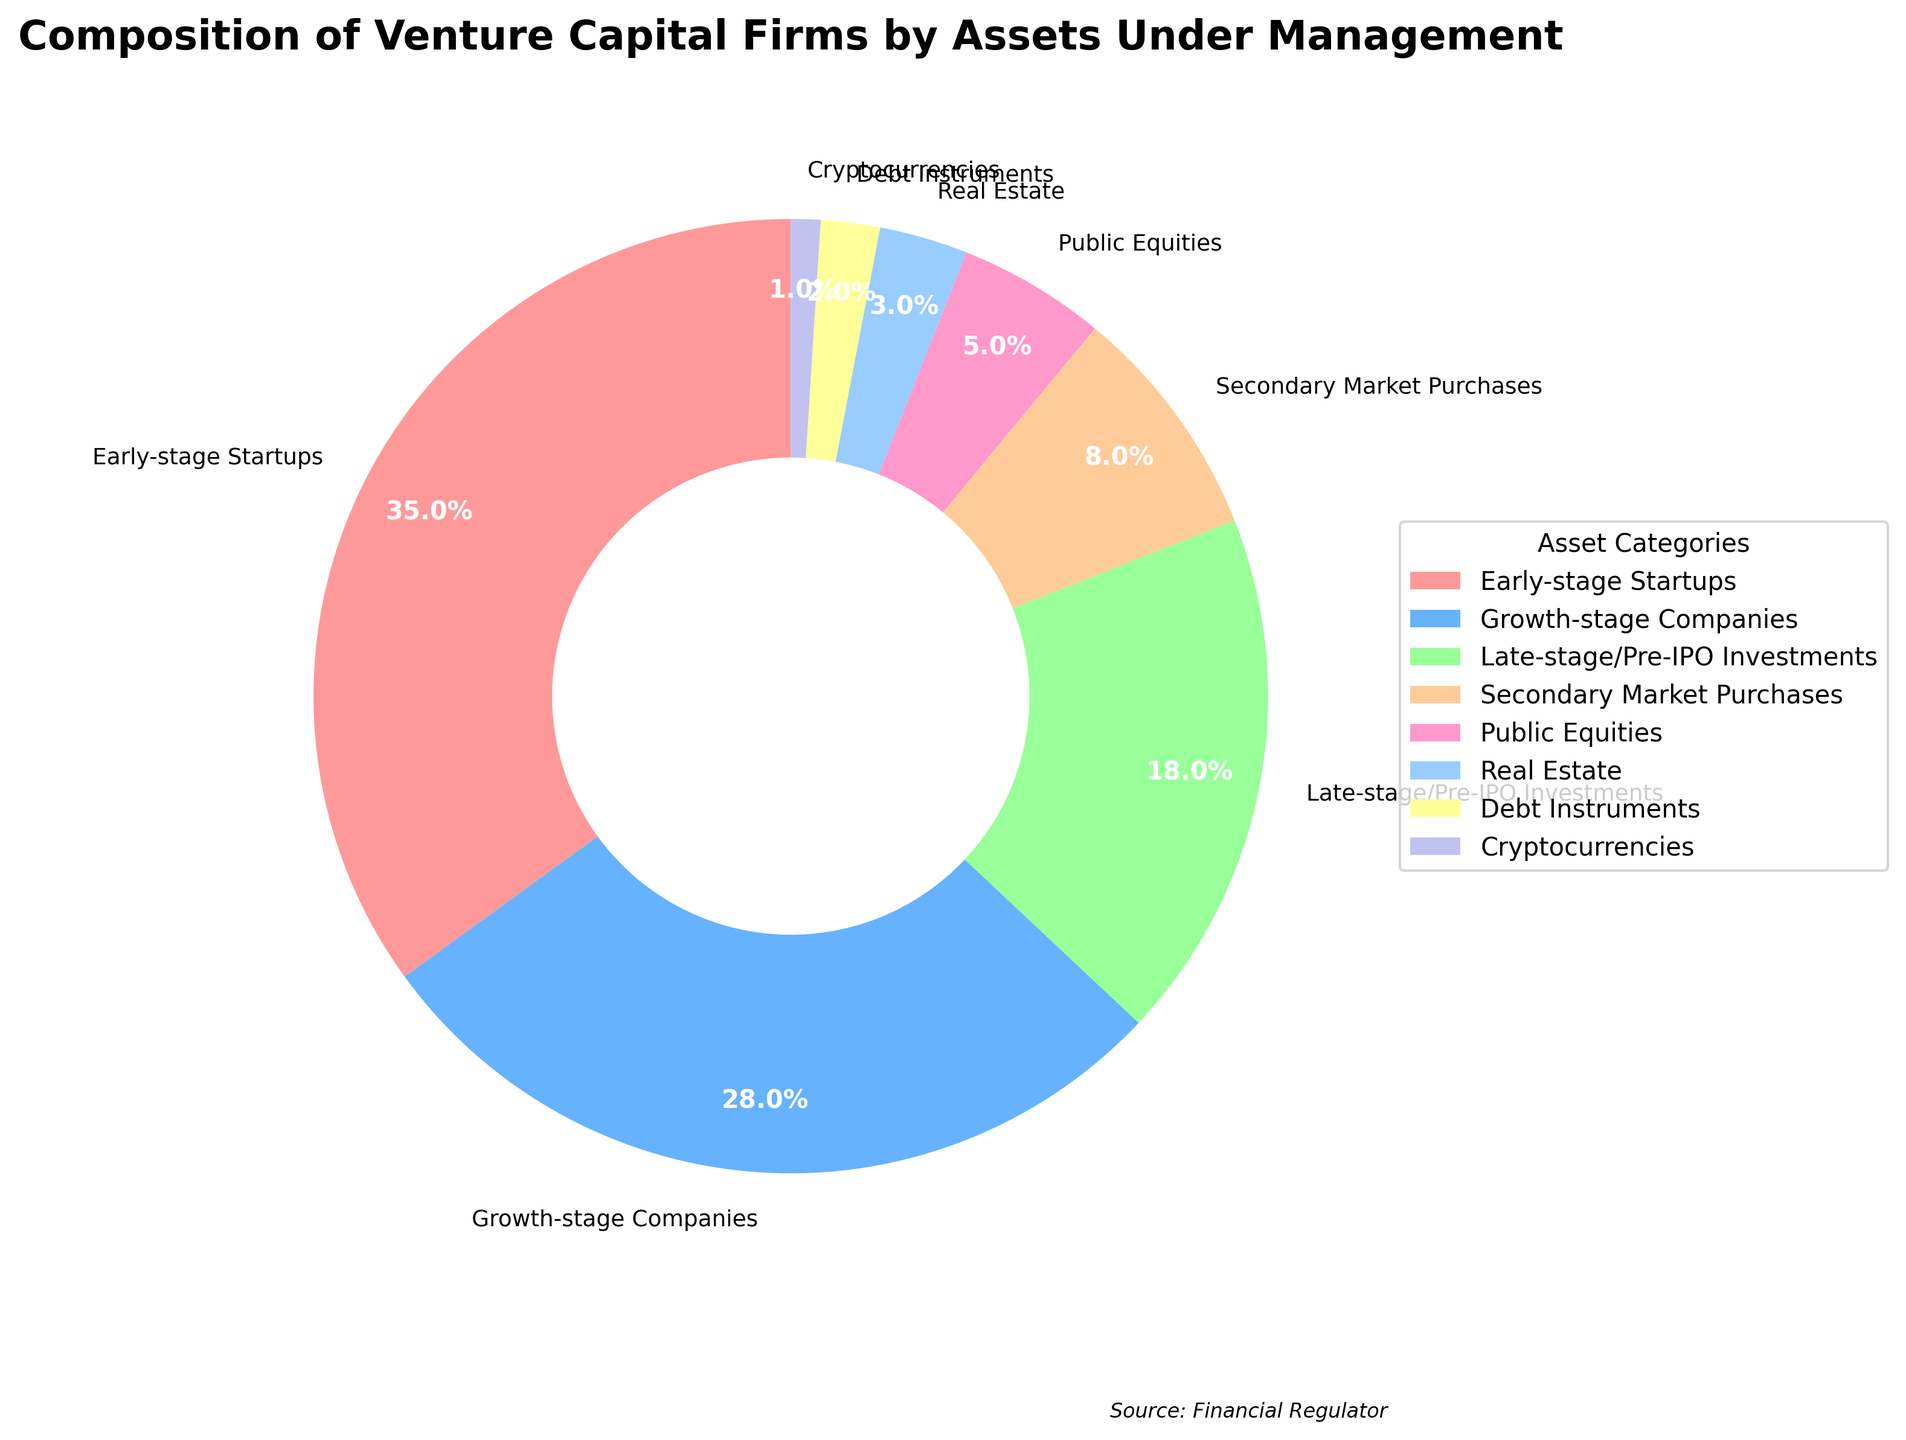Which asset category holds the largest percentage of venture capital firms' assets under management? The pie chart shows that "Early-stage Startups" has the largest slice, or segment, which suggests it holds the largest percentage at 35%.
Answer: Early-stage Startups How do the percentages of Growth-stage Companies and Late-stage/Pre-IPO Investments compare? Growth-stage Companies have a percentage of 28%, while Late-stage/Pre-IPO Investments have 18%. To compare, subtract the smaller percentage from the larger: 28% - 18% = 10%.
Answer: Growth-stage Companies have 10% more Which two categories together account for more than half of the assets under management? Adding the percentages of "Early-stage Startups" (35%) and "Growth-stage Companies" (28%) gives us 35% + 28% = 63%, which is more than half (50%).
Answer: Early-stage Startups and Growth-stage Companies Do any asset categories combine to make exactly a quarter of the total assets under management? A quarter is 25%. Adding "Public Equities" (5%), "Real Estate" (3%), "Debt Instruments" (2%), and "Cryptocurrencies" (1%) together gives us 5% + 3% + 2% + 1% = 11%. This does not add up to 25%. However, "Late-stage/Pre-IPO Investments" alone is 18%, and its combination with "Secondary Market Purchases" (8%) equals 18% + 8% = 26%, close to a quarter but not exact. Therefore, the answer is no.
Answer: No Which asset category is represented by the smallest segment, and what is its percentage? The smallest segment on the pie chart belongs to "Cryptocurrencies," which is noted to be 1%.
Answer: Cryptocurrencies What is the combined percentage of non-equity investments (Real Estate, Debt Instruments, and Cryptocurrencies)? Adding the percentages of "Real Estate" (3%), "Debt Instruments" (2%), and "Cryptocurrencies" (1%) gives 3% + 2% + 1% = 6%.
Answer: 6% Is the percentage of Late-stage/Pre-IPO Investments greater than the percentage of Secondary Market Purchases and Public Equities combined? The percentage for "Late-stage/Pre-IPO Investments" is 18%. The combined percentage for "Secondary Market Purchases" (8%) and "Public Equities" (5%) is 8% + 5% = 13%. Since 18% > 13%, the percentage of Late-stage/Pre-IPO Investments is indeed greater.
Answer: Yes Which asset categories together form the smallest segment greater than 10%? The smallest combination greater than 10% equals "Secondary Market Purchases" (8%) and "Public Equities" (5%), summing to 8% + 5% = 13%.
Answer: Secondary Market Purchases and Public Equities How much greater is the percentage of Early-stage Startups compared to Real Estate and Debt Instruments combined? The percentage for "Early-stage Startups" is 35%. The combined percentage for "Real Estate" (3%) and "Debt Instruments" (2%) is 3% + 2% = 5%. So, 35% - 5% = 30%.
Answer: 30% Which category has exactly one-third the percentage of Early-stage Startups? One-third of 35% (Early-stage Startups) is 35% / 3 ≈ 11.67%. Checking the other categories, "Secondary Market Purchases" (8%) is not exactly one-third but is closest. No category is exactly one-third.
Answer: None 